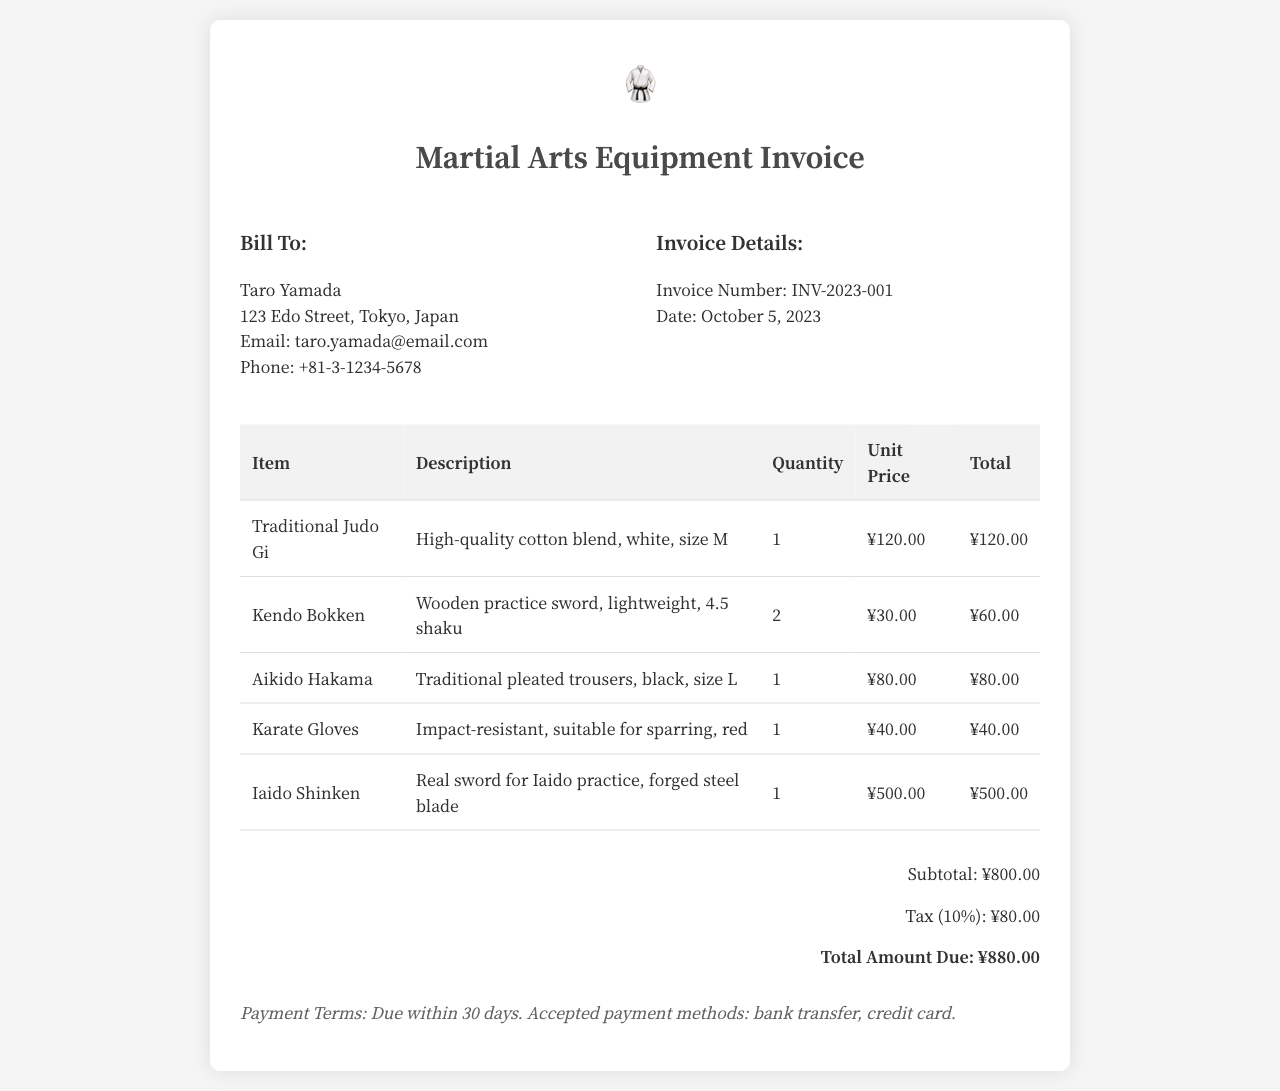what is the invoice number? The invoice number is a unique identifier for this billing document, listed clearly in the invoice details.
Answer: INV-2023-001 what is the date of the invoice? The date indicates when the invoice was issued, which is specified in the invoice details section.
Answer: October 5, 2023 who is the bill to? The 'Bill To' section of the invoice specifies the name of the customer to whom the invoice is issued.
Answer: Taro Yamada how many Kendo Bokken are listed? The quantity of each item appears in the invoice table, which states the number of Kendo Bokken purchased.
Answer: 2 what is the total amount due? The total amount due is calculated by summing the subtotal and tax, presented at the bottom of the invoice.
Answer: ¥880.00 which item has the highest unit price? The unit prices for all items are listed; identifying the highest price allows us to find the most expensive item.
Answer: Iaido Shinken what is the subtotal amount? The subtotal reflects the total of all item prices before tax and is shown in the total section of the invoice.
Answer: ¥800.00 what is the payment term? This section specifies the conditions under which the payment must be made, mentioned towards the end of the invoice.
Answer: Due within 30 days 